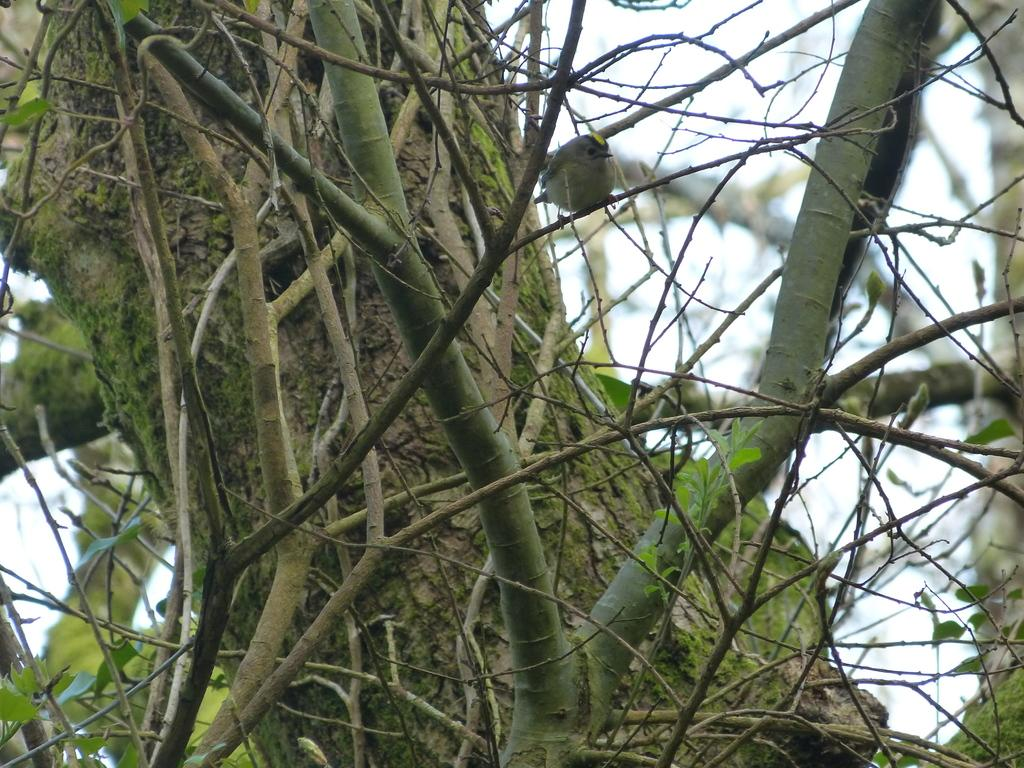What is the main subject in the front of the image? There are branches of a tree in the front of the image. Can you describe the branches in more detail? The branches appear to be from a tree, and they may have leaves or other vegetation on them. What can be inferred about the location of the image based on the presence of the tree branches? The image was likely taken outdoors, where trees are commonly found. What type of crook can be seen hiding behind the tree branches in the image? There is no crook present in the image; it features only the branches of a tree. How many eggs are visible on the tree branches in the image? There are no eggs visible on the tree branches in the image. 